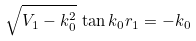Convert formula to latex. <formula><loc_0><loc_0><loc_500><loc_500>\sqrt { V _ { 1 } - k _ { 0 } ^ { 2 } } \, \tan k _ { 0 } r _ { 1 } = - k _ { 0 }</formula> 